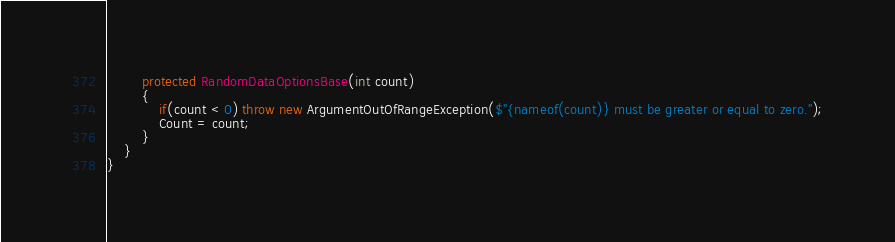<code> <loc_0><loc_0><loc_500><loc_500><_C#_>        protected RandomDataOptionsBase(int count)
        {
            if(count < 0) throw new ArgumentOutOfRangeException($"{nameof(count)} must be greater or equal to zero.");
            Count = count;
        }
    }
}</code> 